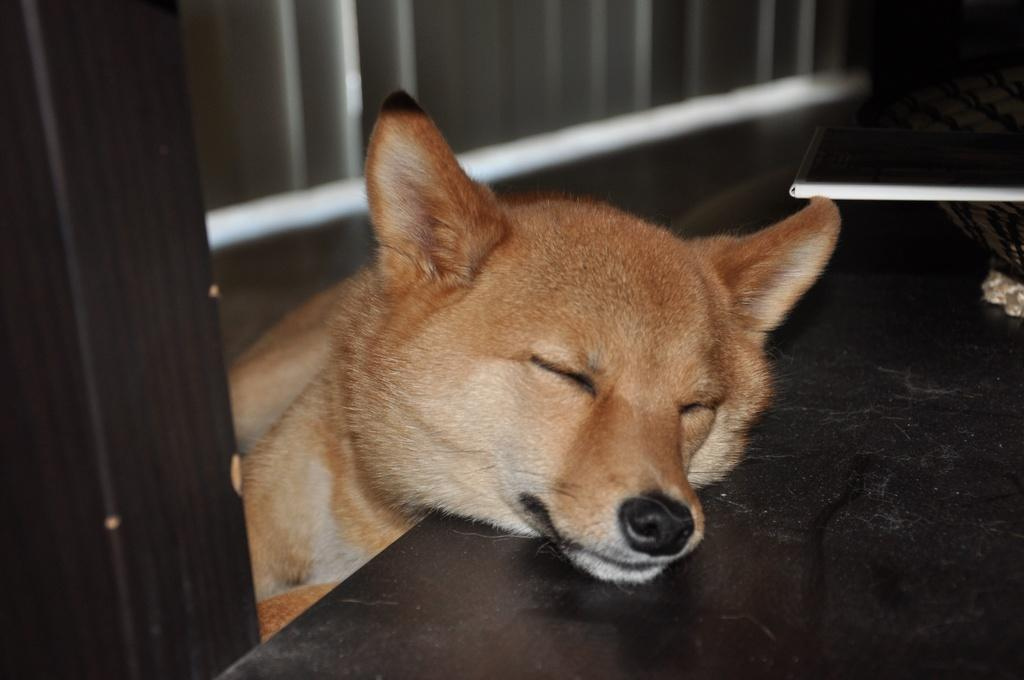What type of animal can be seen in the image? There is a dog in the image. What color is the dog? The dog is brown in color. Where is the dog located in the image? The dog is sleeping on a table. What is the color of the table? The table is black in color. What object can be seen on the right side of the image? There is a book on the right side of the image. What type of pizzas is the dog eating in the image? There are no pizzas present in the image; the dog is sleeping on a table. 